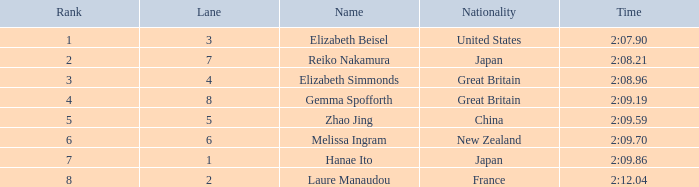What is Laure Manaudou's highest rank? 8.0. 